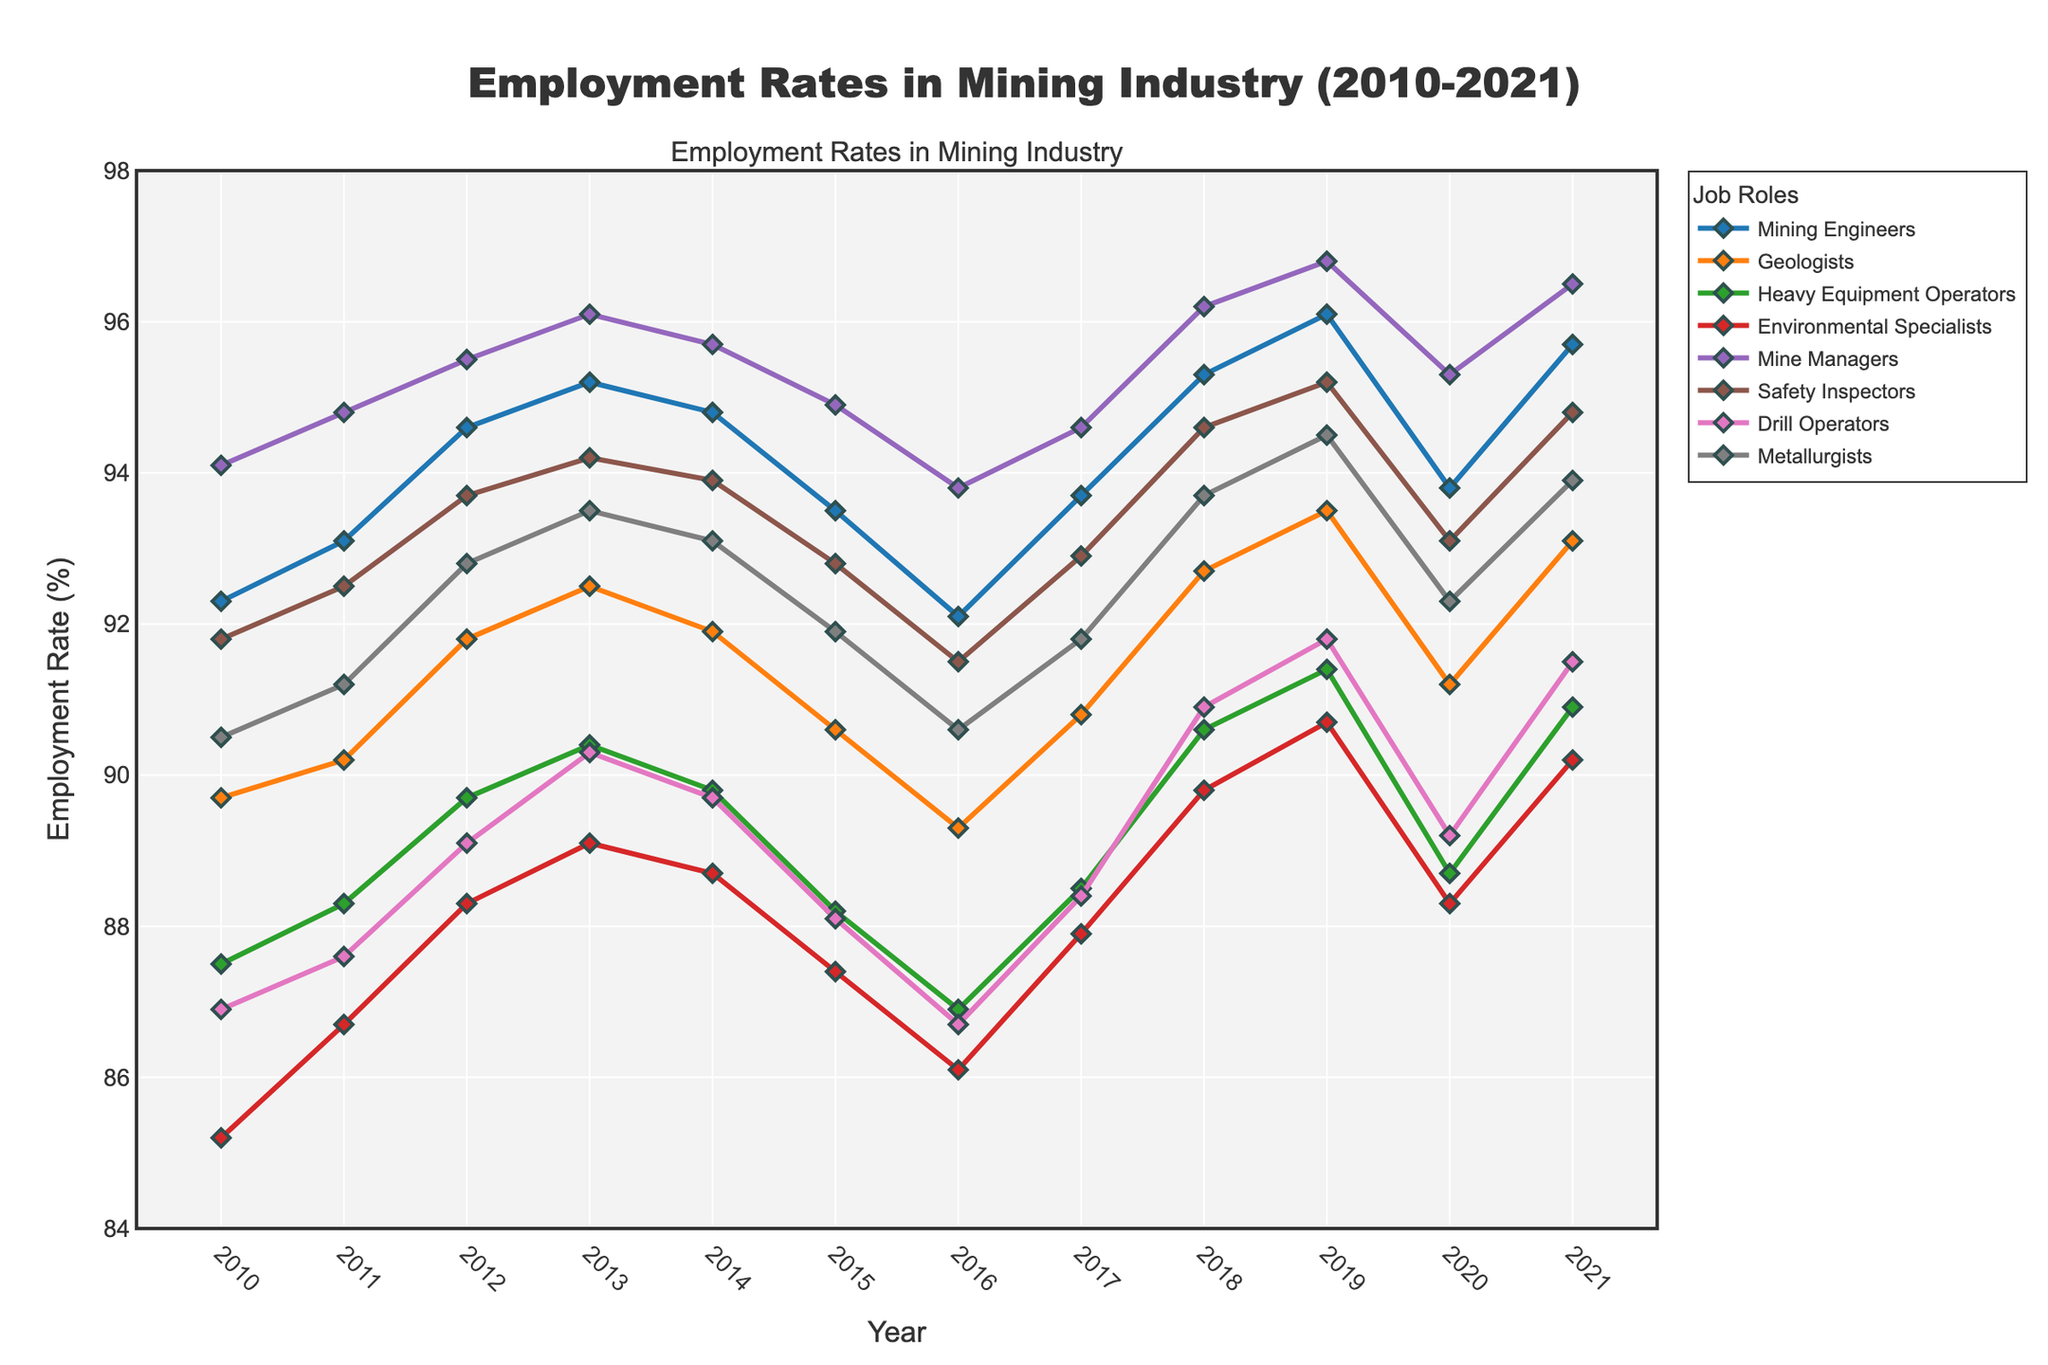What was the employment rate for Mining Engineers in 2015? Locate the line corresponding to Mining Engineers (blue) on the chart, then follow it to the year 2015 on the x-axis. The corresponding y-value shows the employment rate for that year.
Answer: 93.5% Which job role had the highest employment rate in 2011? Look at the lines for all job roles. The job role with the highest y-value in 2011 on the x-axis has the highest employment rate.
Answer: Mine Managers By how many percentage points did the employment rate of Safety Inspectors change from 2016 to 2018? Identify the y-values for Safety Inspectors (orange) in 2016 and 2018. Subtract the 2016 value from the 2018 value: 94.6 - 91.5 = 3.1.
Answer: 3.1 Which two job roles had the closest employment rates in 2021, and what were those rates? Compare the y-values for all job roles in 2021. The closest two y-values are for Drill Operators (91.5%) and Heavy Equipment Operators (90.9%).
Answer: Drill Operators (91.5%) and Heavy Equipment Operators (90.9%) From 2010 to 2021, which job role had the most fluctuating employment rates? Evaluate the variability of each line throughout the years. The most fluctuating line is for Heavy Equipment Operators due to its visible variations.
Answer: Heavy Equipment Operators Which year saw the highest overall employment rate across all job roles, and what was that rate? Examine the peaks for all lines across the chart. The highest overall employment rate occurs for Mine Managers in 2019 at 96.8%.
Answer: 2019, 96.8% What is the average employment rate for Geologists over the period from 2010 to 2021? Sum the employment rates for Geologists from 2010 to 2021 and divide by the number of years: (89.7 + 90.2 + 91.8 + 92.5 + 91.9 + 90.6 + 89.3 + 90.8 + 92.7 + 93.5 + 91.2 + 93.1) / 12 = 91.3.
Answer: 91.3 Did any job role experience a consistent annual increase in employment rates from 2010 to 2020? Observe the trend of each line from 2010 to 2020. Mine Managers show a consistent increase until 2020, though with minor fluctuations.
Answer: No job role had a consistent annual increase 